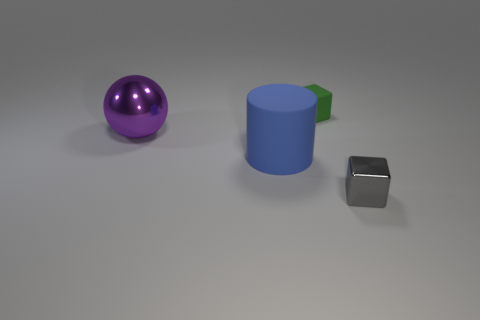How many other things are there of the same size as the gray block?
Provide a succinct answer. 1. Is there a green matte object of the same shape as the gray metallic thing?
Provide a short and direct response. Yes. What size is the metal object on the left side of the block that is in front of the blue rubber object?
Your answer should be very brief. Large. The object on the right side of the thing that is behind the metal thing that is behind the tiny gray metal cube is what shape?
Provide a short and direct response. Cube. There is a cylinder that is the same material as the green thing; what size is it?
Keep it short and to the point. Large. Are there more matte blocks than large brown matte cylinders?
Provide a succinct answer. Yes. There is another block that is the same size as the rubber block; what is it made of?
Your response must be concise. Metal. There is a shiny thing that is left of the gray thing; does it have the same size as the matte cylinder?
Provide a succinct answer. Yes. How many cylinders are small green matte things or gray metal things?
Make the answer very short. 0. There is a small object that is behind the big blue rubber object; what is its material?
Give a very brief answer. Rubber. 